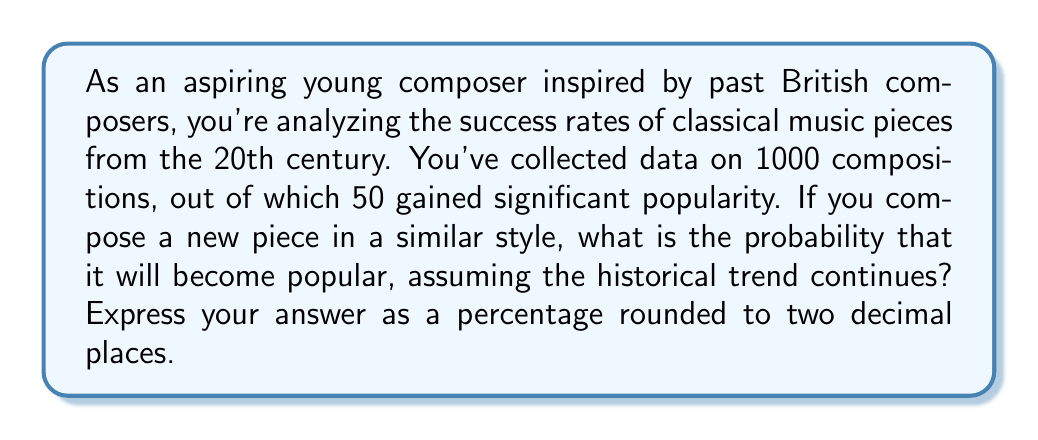Give your solution to this math problem. To solve this problem, we need to use the concept of relative frequency as an estimate of probability. The steps are as follows:

1. Identify the total number of compositions: $n = 1000$

2. Identify the number of popular compositions: $k = 50$

3. Calculate the probability using the formula:

   $$P(\text{popular}) = \frac{\text{number of popular compositions}}{\text{total number of compositions}}$$

   $$P(\text{popular}) = \frac{k}{n} = \frac{50}{1000} = 0.05$$

4. Convert the probability to a percentage:

   $$\text{Percentage} = P(\text{popular}) \times 100\% = 0.05 \times 100\% = 5\%$$

5. Round the result to two decimal places:

   $$5.00\%$$

This calculation assumes that the historical trend continues and that your composition style is similar to those in the dataset. It's important to note that actual success can depend on many factors beyond historical trends.
Answer: 5.00% 